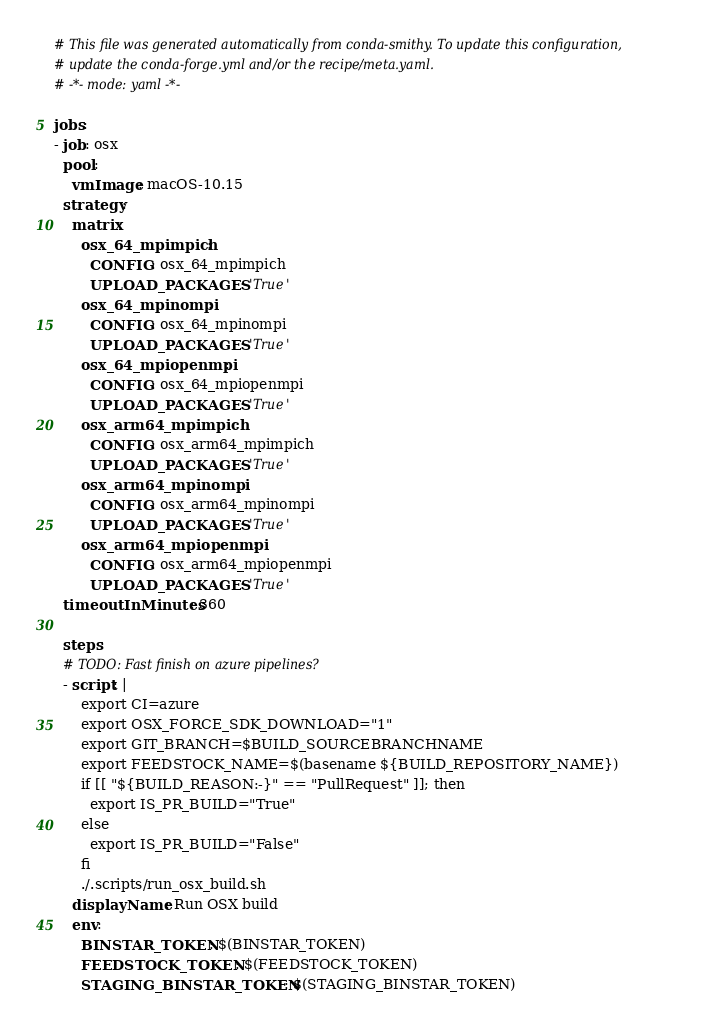<code> <loc_0><loc_0><loc_500><loc_500><_YAML_># This file was generated automatically from conda-smithy. To update this configuration,
# update the conda-forge.yml and/or the recipe/meta.yaml.
# -*- mode: yaml -*-

jobs:
- job: osx
  pool:
    vmImage: macOS-10.15
  strategy:
    matrix:
      osx_64_mpimpich:
        CONFIG: osx_64_mpimpich
        UPLOAD_PACKAGES: 'True'
      osx_64_mpinompi:
        CONFIG: osx_64_mpinompi
        UPLOAD_PACKAGES: 'True'
      osx_64_mpiopenmpi:
        CONFIG: osx_64_mpiopenmpi
        UPLOAD_PACKAGES: 'True'
      osx_arm64_mpimpich:
        CONFIG: osx_arm64_mpimpich
        UPLOAD_PACKAGES: 'True'
      osx_arm64_mpinompi:
        CONFIG: osx_arm64_mpinompi
        UPLOAD_PACKAGES: 'True'
      osx_arm64_mpiopenmpi:
        CONFIG: osx_arm64_mpiopenmpi
        UPLOAD_PACKAGES: 'True'
  timeoutInMinutes: 360

  steps:
  # TODO: Fast finish on azure pipelines?
  - script: |
      export CI=azure
      export OSX_FORCE_SDK_DOWNLOAD="1"
      export GIT_BRANCH=$BUILD_SOURCEBRANCHNAME
      export FEEDSTOCK_NAME=$(basename ${BUILD_REPOSITORY_NAME})
      if [[ "${BUILD_REASON:-}" == "PullRequest" ]]; then
        export IS_PR_BUILD="True"
      else
        export IS_PR_BUILD="False"
      fi
      ./.scripts/run_osx_build.sh
    displayName: Run OSX build
    env:
      BINSTAR_TOKEN: $(BINSTAR_TOKEN)
      FEEDSTOCK_TOKEN: $(FEEDSTOCK_TOKEN)
      STAGING_BINSTAR_TOKEN: $(STAGING_BINSTAR_TOKEN)</code> 